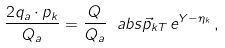Convert formula to latex. <formula><loc_0><loc_0><loc_500><loc_500>\frac { 2 q _ { a } \cdot p _ { k } } { Q _ { a } } = \frac { Q } { Q _ { a } } \ a b s { \vec { p } _ { k T } } \, e ^ { Y - \eta _ { k } } \, ,</formula> 